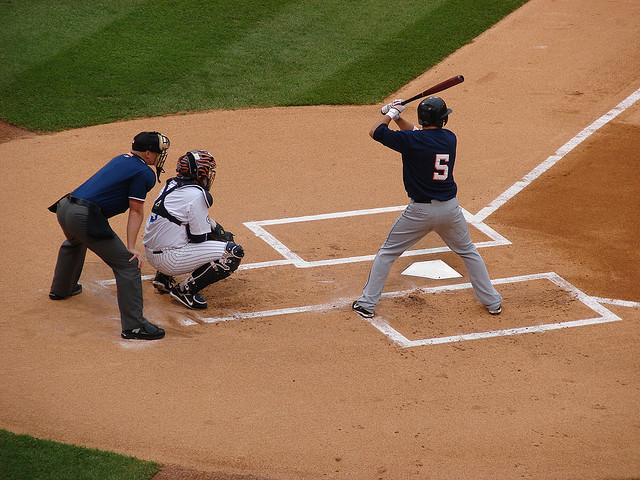Rawlings are the helmets used by whom? baseball players 